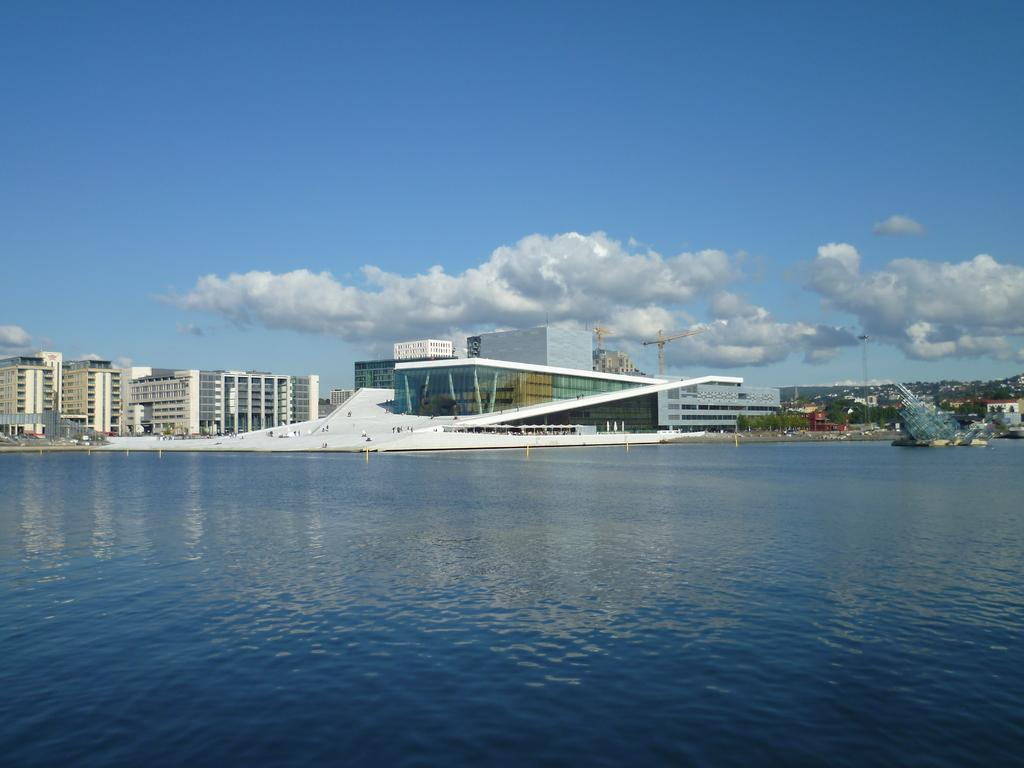What type of location is depicted at the bottom of the image? There is a beach at the bottom of the image. What structures can be seen in the center of the image? There are buildings and towers in the center of the image. What is visible at the top of the image? The sky is visible at the top of the image. What type of chalk is being used to draw on the beach in the image? There is no chalk or drawing activity present in the image. What is being served for breakfast in the image? There is no reference to breakfast or food in the image. 